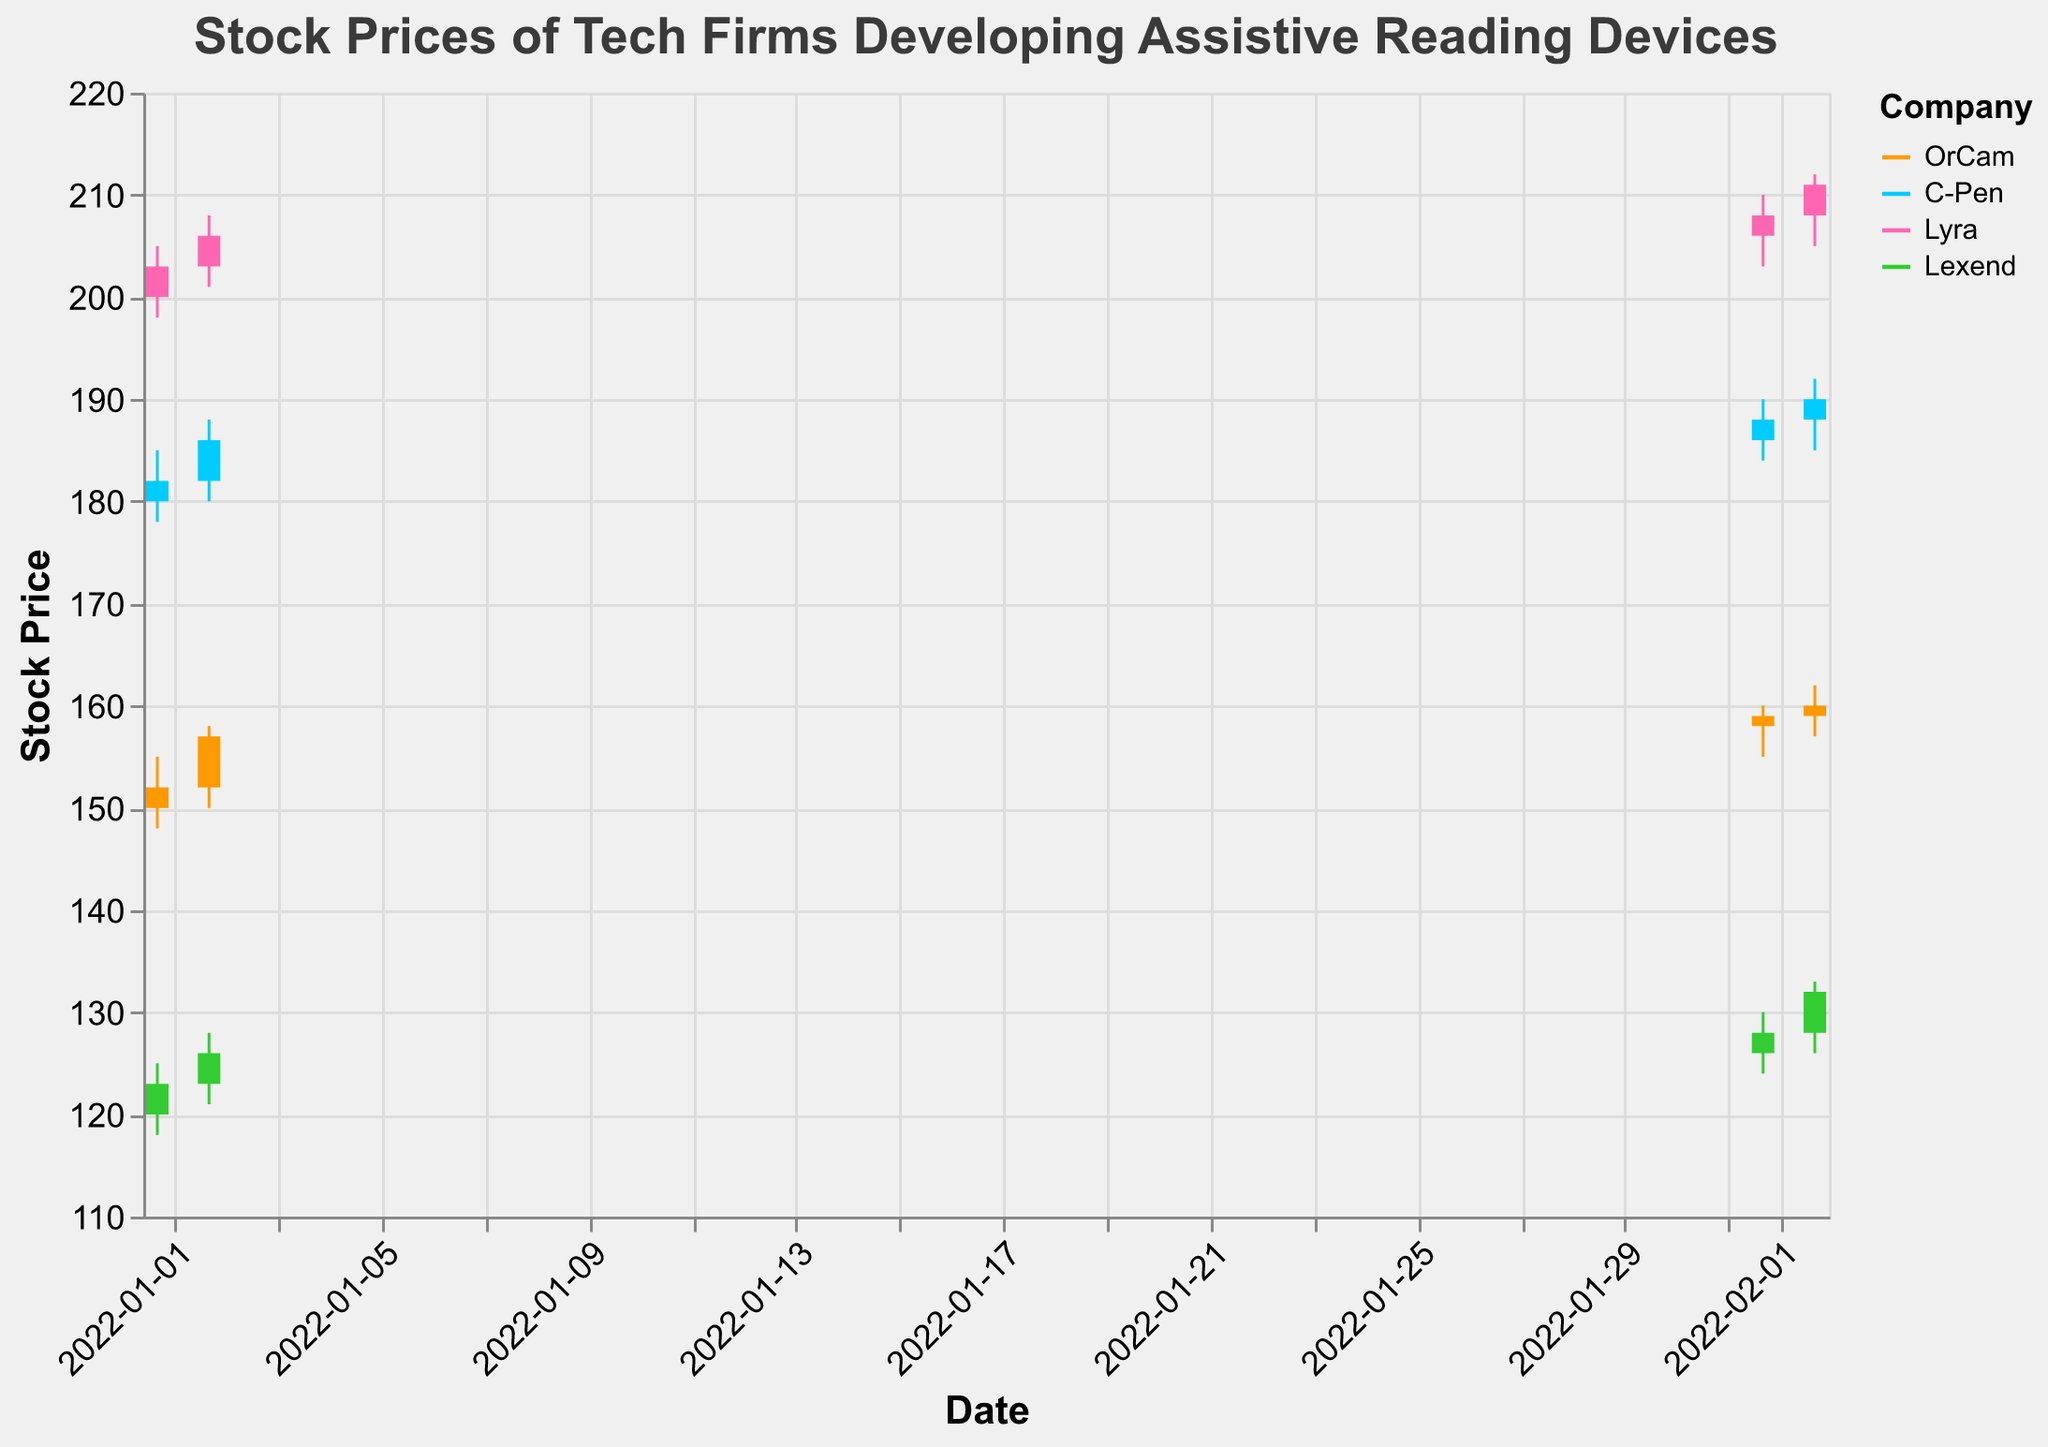Which company had the highest closing stock price on 2022-02-02? To determine this, locate the closing prices for all companies on 2022-02-02. OrCam closed at 160, C-Pen at 190, Lyra at 211, and Lexend at 132. Lyra has the highest closing price.
Answer: Lyra What was the opening price of C-Pen on 2022-01-01 and how much did it increase by 2022-02-02? Find the opening prices of C-Pen on 2022-01-01 and 2022-02-02. The opening price on 2022-01-01 was 180 and on 2022-02-02, it was 188. The increase is 188 - 180 = 8.
Answer: 8 Which company showed the largest gain in stock price from January to February? Calculate the difference in closing prices from January 02 to February 02 for each company. OrCam: 160-157=3, C-Pen: 190-186=4, Lyra: 211-206=5, Lexend: 132-126=6. Lexend showed the largest gain.
Answer: Lexend Which company's stock had the highest volume of transactions on 2022-02-02? Look at the volume of stocks traded on 2022-02-02 for each company. OrCam had a volume of 13500, C-Pen had 16500, Lyra had 7800, and Lexend had 19500. Lexend had the highest volume.
Answer: Lexend Did any company's stock price drop from 2022-01-02 to 2022-02-01? Check the closing prices of all companies on 2022-01-02 and 2022-02-01. Compare the values: OrCam increased from 157 to 159, C-Pen increased from 186 to 188, Lyra increased from 206 to 208, Lexend increased from 126 to 128. No company's stock price dropped.
Answer: No What was the difference in the highest stock price (High) between OrCam and Lyra on 2022-01-02? Compare the highest stock prices on 2022-01-02 for both companies. OrCam's highest price was 158 and Lyra's highest price was 208. The difference is 208 - 158 = 50.
Answer: 50 